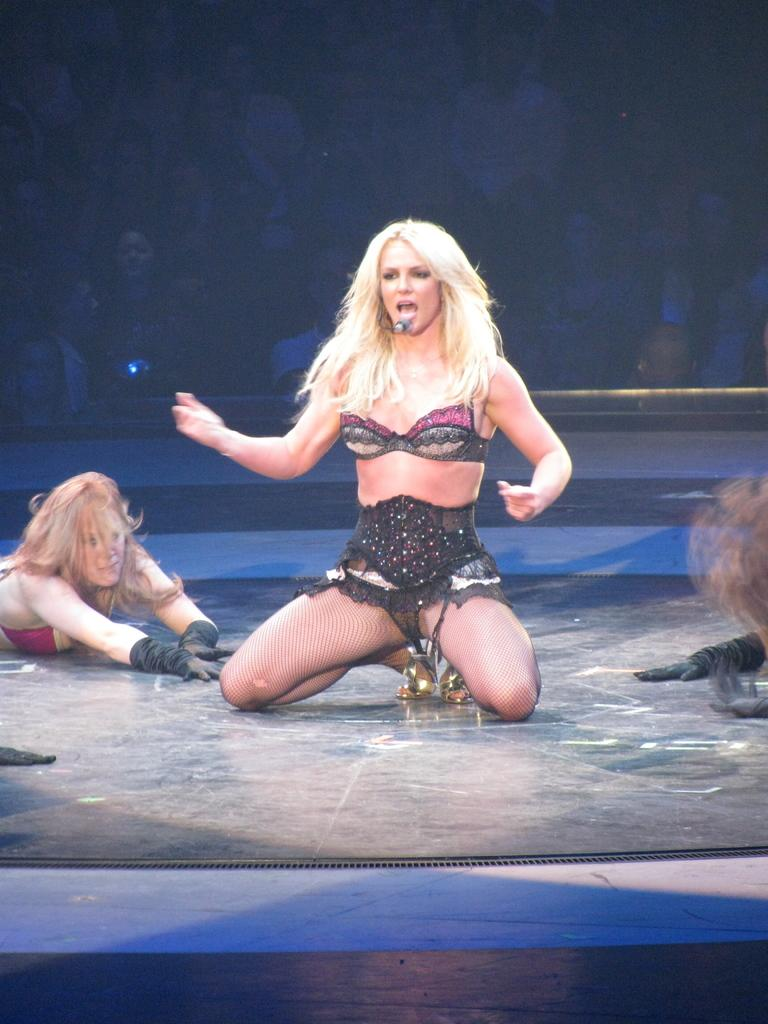How many women are in the image? There are two women in the image. Can you describe the people in the background of the image? Unfortunately, the provided facts do not give any information about the people in the background. What type of paste is being used by the actor in the image? There is no actor or paste present in the image. 